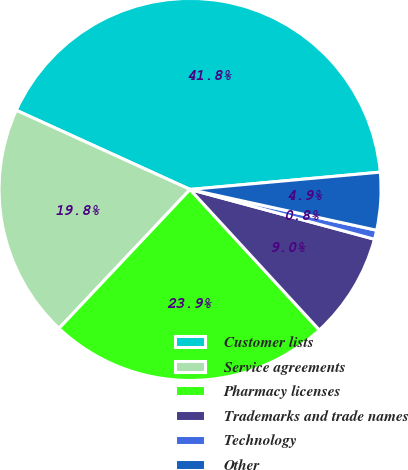Convert chart. <chart><loc_0><loc_0><loc_500><loc_500><pie_chart><fcel>Customer lists<fcel>Service agreements<fcel>Pharmacy licenses<fcel>Trademarks and trade names<fcel>Technology<fcel>Other<nl><fcel>41.75%<fcel>19.77%<fcel>23.87%<fcel>8.97%<fcel>0.77%<fcel>4.87%<nl></chart> 